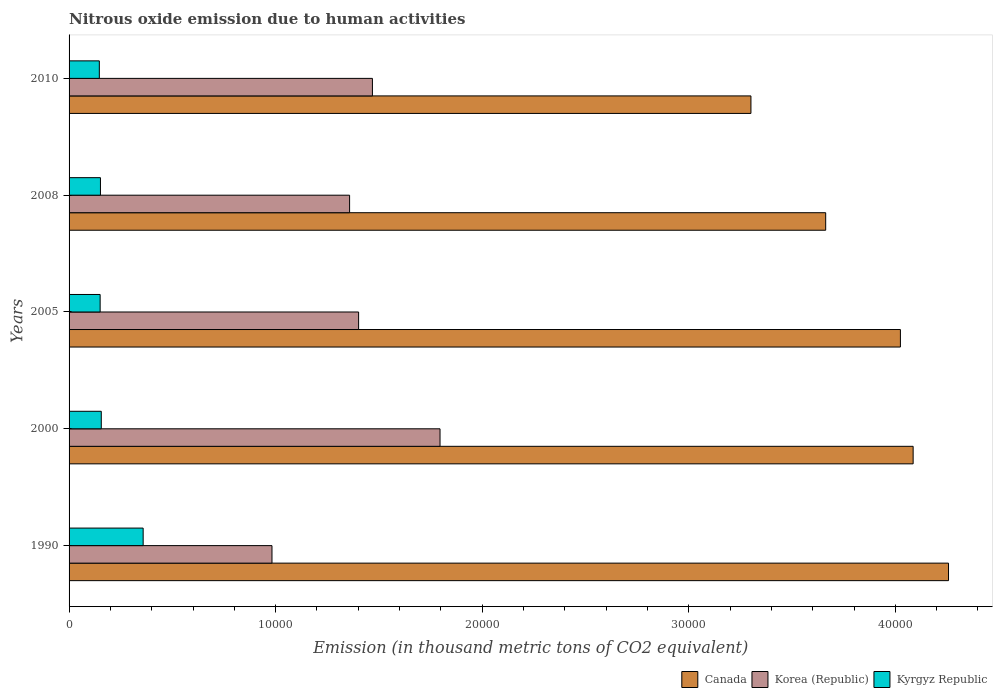Are the number of bars on each tick of the Y-axis equal?
Provide a succinct answer. Yes. What is the label of the 3rd group of bars from the top?
Your answer should be very brief. 2005. What is the amount of nitrous oxide emitted in Korea (Republic) in 2008?
Your answer should be compact. 1.36e+04. Across all years, what is the maximum amount of nitrous oxide emitted in Kyrgyz Republic?
Offer a terse response. 3586.5. Across all years, what is the minimum amount of nitrous oxide emitted in Kyrgyz Republic?
Give a very brief answer. 1465. What is the total amount of nitrous oxide emitted in Korea (Republic) in the graph?
Ensure brevity in your answer.  7.01e+04. What is the difference between the amount of nitrous oxide emitted in Korea (Republic) in 2000 and that in 2010?
Make the answer very short. 3272.5. What is the difference between the amount of nitrous oxide emitted in Korea (Republic) in 2005 and the amount of nitrous oxide emitted in Kyrgyz Republic in 2008?
Offer a very short reply. 1.25e+04. What is the average amount of nitrous oxide emitted in Kyrgyz Republic per year?
Your response must be concise. 1926.84. In the year 2008, what is the difference between the amount of nitrous oxide emitted in Kyrgyz Republic and amount of nitrous oxide emitted in Korea (Republic)?
Your answer should be very brief. -1.21e+04. What is the ratio of the amount of nitrous oxide emitted in Canada in 2005 to that in 2010?
Give a very brief answer. 1.22. Is the amount of nitrous oxide emitted in Korea (Republic) in 2005 less than that in 2008?
Give a very brief answer. No. What is the difference between the highest and the second highest amount of nitrous oxide emitted in Kyrgyz Republic?
Your answer should be compact. 2027.4. What is the difference between the highest and the lowest amount of nitrous oxide emitted in Kyrgyz Republic?
Make the answer very short. 2121.5. In how many years, is the amount of nitrous oxide emitted in Korea (Republic) greater than the average amount of nitrous oxide emitted in Korea (Republic) taken over all years?
Your response must be concise. 3. Is the sum of the amount of nitrous oxide emitted in Korea (Republic) in 1990 and 2008 greater than the maximum amount of nitrous oxide emitted in Kyrgyz Republic across all years?
Offer a very short reply. Yes. What does the 1st bar from the top in 2010 represents?
Provide a succinct answer. Kyrgyz Republic. How many bars are there?
Provide a short and direct response. 15. Are all the bars in the graph horizontal?
Your response must be concise. Yes. How many years are there in the graph?
Ensure brevity in your answer.  5. Are the values on the major ticks of X-axis written in scientific E-notation?
Provide a succinct answer. No. Does the graph contain grids?
Your answer should be compact. No. How are the legend labels stacked?
Your answer should be very brief. Horizontal. What is the title of the graph?
Your response must be concise. Nitrous oxide emission due to human activities. Does "Northern Mariana Islands" appear as one of the legend labels in the graph?
Ensure brevity in your answer.  No. What is the label or title of the X-axis?
Your answer should be very brief. Emission (in thousand metric tons of CO2 equivalent). What is the label or title of the Y-axis?
Provide a short and direct response. Years. What is the Emission (in thousand metric tons of CO2 equivalent) in Canada in 1990?
Offer a very short reply. 4.26e+04. What is the Emission (in thousand metric tons of CO2 equivalent) in Korea (Republic) in 1990?
Give a very brief answer. 9823.4. What is the Emission (in thousand metric tons of CO2 equivalent) in Kyrgyz Republic in 1990?
Your answer should be very brief. 3586.5. What is the Emission (in thousand metric tons of CO2 equivalent) of Canada in 2000?
Offer a terse response. 4.09e+04. What is the Emission (in thousand metric tons of CO2 equivalent) in Korea (Republic) in 2000?
Ensure brevity in your answer.  1.80e+04. What is the Emission (in thousand metric tons of CO2 equivalent) of Kyrgyz Republic in 2000?
Give a very brief answer. 1559.1. What is the Emission (in thousand metric tons of CO2 equivalent) in Canada in 2005?
Provide a succinct answer. 4.02e+04. What is the Emission (in thousand metric tons of CO2 equivalent) in Korea (Republic) in 2005?
Make the answer very short. 1.40e+04. What is the Emission (in thousand metric tons of CO2 equivalent) in Kyrgyz Republic in 2005?
Provide a short and direct response. 1504.3. What is the Emission (in thousand metric tons of CO2 equivalent) in Canada in 2008?
Offer a very short reply. 3.66e+04. What is the Emission (in thousand metric tons of CO2 equivalent) in Korea (Republic) in 2008?
Your response must be concise. 1.36e+04. What is the Emission (in thousand metric tons of CO2 equivalent) of Kyrgyz Republic in 2008?
Offer a very short reply. 1519.3. What is the Emission (in thousand metric tons of CO2 equivalent) of Canada in 2010?
Ensure brevity in your answer.  3.30e+04. What is the Emission (in thousand metric tons of CO2 equivalent) of Korea (Republic) in 2010?
Make the answer very short. 1.47e+04. What is the Emission (in thousand metric tons of CO2 equivalent) of Kyrgyz Republic in 2010?
Your response must be concise. 1465. Across all years, what is the maximum Emission (in thousand metric tons of CO2 equivalent) of Canada?
Give a very brief answer. 4.26e+04. Across all years, what is the maximum Emission (in thousand metric tons of CO2 equivalent) in Korea (Republic)?
Your answer should be compact. 1.80e+04. Across all years, what is the maximum Emission (in thousand metric tons of CO2 equivalent) in Kyrgyz Republic?
Offer a terse response. 3586.5. Across all years, what is the minimum Emission (in thousand metric tons of CO2 equivalent) of Canada?
Your response must be concise. 3.30e+04. Across all years, what is the minimum Emission (in thousand metric tons of CO2 equivalent) of Korea (Republic)?
Your response must be concise. 9823.4. Across all years, what is the minimum Emission (in thousand metric tons of CO2 equivalent) in Kyrgyz Republic?
Your answer should be very brief. 1465. What is the total Emission (in thousand metric tons of CO2 equivalent) in Canada in the graph?
Give a very brief answer. 1.93e+05. What is the total Emission (in thousand metric tons of CO2 equivalent) of Korea (Republic) in the graph?
Your response must be concise. 7.01e+04. What is the total Emission (in thousand metric tons of CO2 equivalent) in Kyrgyz Republic in the graph?
Provide a succinct answer. 9634.2. What is the difference between the Emission (in thousand metric tons of CO2 equivalent) in Canada in 1990 and that in 2000?
Your answer should be very brief. 1712.6. What is the difference between the Emission (in thousand metric tons of CO2 equivalent) of Korea (Republic) in 1990 and that in 2000?
Provide a succinct answer. -8134.7. What is the difference between the Emission (in thousand metric tons of CO2 equivalent) of Kyrgyz Republic in 1990 and that in 2000?
Provide a succinct answer. 2027.4. What is the difference between the Emission (in thousand metric tons of CO2 equivalent) in Canada in 1990 and that in 2005?
Ensure brevity in your answer.  2329.2. What is the difference between the Emission (in thousand metric tons of CO2 equivalent) in Korea (Republic) in 1990 and that in 2005?
Give a very brief answer. -4193. What is the difference between the Emission (in thousand metric tons of CO2 equivalent) of Kyrgyz Republic in 1990 and that in 2005?
Your answer should be very brief. 2082.2. What is the difference between the Emission (in thousand metric tons of CO2 equivalent) in Canada in 1990 and that in 2008?
Keep it short and to the point. 5946.6. What is the difference between the Emission (in thousand metric tons of CO2 equivalent) of Korea (Republic) in 1990 and that in 2008?
Your answer should be very brief. -3756.8. What is the difference between the Emission (in thousand metric tons of CO2 equivalent) in Kyrgyz Republic in 1990 and that in 2008?
Ensure brevity in your answer.  2067.2. What is the difference between the Emission (in thousand metric tons of CO2 equivalent) of Canada in 1990 and that in 2010?
Offer a very short reply. 9564.7. What is the difference between the Emission (in thousand metric tons of CO2 equivalent) of Korea (Republic) in 1990 and that in 2010?
Your answer should be very brief. -4862.2. What is the difference between the Emission (in thousand metric tons of CO2 equivalent) in Kyrgyz Republic in 1990 and that in 2010?
Offer a terse response. 2121.5. What is the difference between the Emission (in thousand metric tons of CO2 equivalent) in Canada in 2000 and that in 2005?
Give a very brief answer. 616.6. What is the difference between the Emission (in thousand metric tons of CO2 equivalent) of Korea (Republic) in 2000 and that in 2005?
Offer a terse response. 3941.7. What is the difference between the Emission (in thousand metric tons of CO2 equivalent) in Kyrgyz Republic in 2000 and that in 2005?
Give a very brief answer. 54.8. What is the difference between the Emission (in thousand metric tons of CO2 equivalent) of Canada in 2000 and that in 2008?
Give a very brief answer. 4234. What is the difference between the Emission (in thousand metric tons of CO2 equivalent) in Korea (Republic) in 2000 and that in 2008?
Ensure brevity in your answer.  4377.9. What is the difference between the Emission (in thousand metric tons of CO2 equivalent) of Kyrgyz Republic in 2000 and that in 2008?
Your response must be concise. 39.8. What is the difference between the Emission (in thousand metric tons of CO2 equivalent) of Canada in 2000 and that in 2010?
Your response must be concise. 7852.1. What is the difference between the Emission (in thousand metric tons of CO2 equivalent) of Korea (Republic) in 2000 and that in 2010?
Your response must be concise. 3272.5. What is the difference between the Emission (in thousand metric tons of CO2 equivalent) in Kyrgyz Republic in 2000 and that in 2010?
Offer a terse response. 94.1. What is the difference between the Emission (in thousand metric tons of CO2 equivalent) of Canada in 2005 and that in 2008?
Offer a terse response. 3617.4. What is the difference between the Emission (in thousand metric tons of CO2 equivalent) in Korea (Republic) in 2005 and that in 2008?
Your response must be concise. 436.2. What is the difference between the Emission (in thousand metric tons of CO2 equivalent) in Kyrgyz Republic in 2005 and that in 2008?
Make the answer very short. -15. What is the difference between the Emission (in thousand metric tons of CO2 equivalent) in Canada in 2005 and that in 2010?
Give a very brief answer. 7235.5. What is the difference between the Emission (in thousand metric tons of CO2 equivalent) of Korea (Republic) in 2005 and that in 2010?
Your answer should be very brief. -669.2. What is the difference between the Emission (in thousand metric tons of CO2 equivalent) in Kyrgyz Republic in 2005 and that in 2010?
Make the answer very short. 39.3. What is the difference between the Emission (in thousand metric tons of CO2 equivalent) of Canada in 2008 and that in 2010?
Ensure brevity in your answer.  3618.1. What is the difference between the Emission (in thousand metric tons of CO2 equivalent) in Korea (Republic) in 2008 and that in 2010?
Ensure brevity in your answer.  -1105.4. What is the difference between the Emission (in thousand metric tons of CO2 equivalent) in Kyrgyz Republic in 2008 and that in 2010?
Your answer should be compact. 54.3. What is the difference between the Emission (in thousand metric tons of CO2 equivalent) in Canada in 1990 and the Emission (in thousand metric tons of CO2 equivalent) in Korea (Republic) in 2000?
Give a very brief answer. 2.46e+04. What is the difference between the Emission (in thousand metric tons of CO2 equivalent) in Canada in 1990 and the Emission (in thousand metric tons of CO2 equivalent) in Kyrgyz Republic in 2000?
Keep it short and to the point. 4.10e+04. What is the difference between the Emission (in thousand metric tons of CO2 equivalent) in Korea (Republic) in 1990 and the Emission (in thousand metric tons of CO2 equivalent) in Kyrgyz Republic in 2000?
Your answer should be compact. 8264.3. What is the difference between the Emission (in thousand metric tons of CO2 equivalent) of Canada in 1990 and the Emission (in thousand metric tons of CO2 equivalent) of Korea (Republic) in 2005?
Keep it short and to the point. 2.86e+04. What is the difference between the Emission (in thousand metric tons of CO2 equivalent) in Canada in 1990 and the Emission (in thousand metric tons of CO2 equivalent) in Kyrgyz Republic in 2005?
Offer a very short reply. 4.11e+04. What is the difference between the Emission (in thousand metric tons of CO2 equivalent) of Korea (Republic) in 1990 and the Emission (in thousand metric tons of CO2 equivalent) of Kyrgyz Republic in 2005?
Keep it short and to the point. 8319.1. What is the difference between the Emission (in thousand metric tons of CO2 equivalent) in Canada in 1990 and the Emission (in thousand metric tons of CO2 equivalent) in Korea (Republic) in 2008?
Keep it short and to the point. 2.90e+04. What is the difference between the Emission (in thousand metric tons of CO2 equivalent) in Canada in 1990 and the Emission (in thousand metric tons of CO2 equivalent) in Kyrgyz Republic in 2008?
Give a very brief answer. 4.11e+04. What is the difference between the Emission (in thousand metric tons of CO2 equivalent) in Korea (Republic) in 1990 and the Emission (in thousand metric tons of CO2 equivalent) in Kyrgyz Republic in 2008?
Offer a terse response. 8304.1. What is the difference between the Emission (in thousand metric tons of CO2 equivalent) of Canada in 1990 and the Emission (in thousand metric tons of CO2 equivalent) of Korea (Republic) in 2010?
Make the answer very short. 2.79e+04. What is the difference between the Emission (in thousand metric tons of CO2 equivalent) in Canada in 1990 and the Emission (in thousand metric tons of CO2 equivalent) in Kyrgyz Republic in 2010?
Your response must be concise. 4.11e+04. What is the difference between the Emission (in thousand metric tons of CO2 equivalent) of Korea (Republic) in 1990 and the Emission (in thousand metric tons of CO2 equivalent) of Kyrgyz Republic in 2010?
Offer a very short reply. 8358.4. What is the difference between the Emission (in thousand metric tons of CO2 equivalent) of Canada in 2000 and the Emission (in thousand metric tons of CO2 equivalent) of Korea (Republic) in 2005?
Keep it short and to the point. 2.68e+04. What is the difference between the Emission (in thousand metric tons of CO2 equivalent) of Canada in 2000 and the Emission (in thousand metric tons of CO2 equivalent) of Kyrgyz Republic in 2005?
Offer a very short reply. 3.94e+04. What is the difference between the Emission (in thousand metric tons of CO2 equivalent) in Korea (Republic) in 2000 and the Emission (in thousand metric tons of CO2 equivalent) in Kyrgyz Republic in 2005?
Offer a terse response. 1.65e+04. What is the difference between the Emission (in thousand metric tons of CO2 equivalent) in Canada in 2000 and the Emission (in thousand metric tons of CO2 equivalent) in Korea (Republic) in 2008?
Provide a short and direct response. 2.73e+04. What is the difference between the Emission (in thousand metric tons of CO2 equivalent) in Canada in 2000 and the Emission (in thousand metric tons of CO2 equivalent) in Kyrgyz Republic in 2008?
Your answer should be compact. 3.93e+04. What is the difference between the Emission (in thousand metric tons of CO2 equivalent) of Korea (Republic) in 2000 and the Emission (in thousand metric tons of CO2 equivalent) of Kyrgyz Republic in 2008?
Provide a short and direct response. 1.64e+04. What is the difference between the Emission (in thousand metric tons of CO2 equivalent) in Canada in 2000 and the Emission (in thousand metric tons of CO2 equivalent) in Korea (Republic) in 2010?
Offer a terse response. 2.62e+04. What is the difference between the Emission (in thousand metric tons of CO2 equivalent) in Canada in 2000 and the Emission (in thousand metric tons of CO2 equivalent) in Kyrgyz Republic in 2010?
Make the answer very short. 3.94e+04. What is the difference between the Emission (in thousand metric tons of CO2 equivalent) of Korea (Republic) in 2000 and the Emission (in thousand metric tons of CO2 equivalent) of Kyrgyz Republic in 2010?
Offer a very short reply. 1.65e+04. What is the difference between the Emission (in thousand metric tons of CO2 equivalent) in Canada in 2005 and the Emission (in thousand metric tons of CO2 equivalent) in Korea (Republic) in 2008?
Your answer should be compact. 2.67e+04. What is the difference between the Emission (in thousand metric tons of CO2 equivalent) in Canada in 2005 and the Emission (in thousand metric tons of CO2 equivalent) in Kyrgyz Republic in 2008?
Make the answer very short. 3.87e+04. What is the difference between the Emission (in thousand metric tons of CO2 equivalent) in Korea (Republic) in 2005 and the Emission (in thousand metric tons of CO2 equivalent) in Kyrgyz Republic in 2008?
Your answer should be very brief. 1.25e+04. What is the difference between the Emission (in thousand metric tons of CO2 equivalent) in Canada in 2005 and the Emission (in thousand metric tons of CO2 equivalent) in Korea (Republic) in 2010?
Ensure brevity in your answer.  2.56e+04. What is the difference between the Emission (in thousand metric tons of CO2 equivalent) of Canada in 2005 and the Emission (in thousand metric tons of CO2 equivalent) of Kyrgyz Republic in 2010?
Your response must be concise. 3.88e+04. What is the difference between the Emission (in thousand metric tons of CO2 equivalent) of Korea (Republic) in 2005 and the Emission (in thousand metric tons of CO2 equivalent) of Kyrgyz Republic in 2010?
Ensure brevity in your answer.  1.26e+04. What is the difference between the Emission (in thousand metric tons of CO2 equivalent) of Canada in 2008 and the Emission (in thousand metric tons of CO2 equivalent) of Korea (Republic) in 2010?
Offer a terse response. 2.19e+04. What is the difference between the Emission (in thousand metric tons of CO2 equivalent) of Canada in 2008 and the Emission (in thousand metric tons of CO2 equivalent) of Kyrgyz Republic in 2010?
Your answer should be compact. 3.52e+04. What is the difference between the Emission (in thousand metric tons of CO2 equivalent) in Korea (Republic) in 2008 and the Emission (in thousand metric tons of CO2 equivalent) in Kyrgyz Republic in 2010?
Your response must be concise. 1.21e+04. What is the average Emission (in thousand metric tons of CO2 equivalent) of Canada per year?
Make the answer very short. 3.87e+04. What is the average Emission (in thousand metric tons of CO2 equivalent) in Korea (Republic) per year?
Give a very brief answer. 1.40e+04. What is the average Emission (in thousand metric tons of CO2 equivalent) in Kyrgyz Republic per year?
Provide a succinct answer. 1926.84. In the year 1990, what is the difference between the Emission (in thousand metric tons of CO2 equivalent) in Canada and Emission (in thousand metric tons of CO2 equivalent) in Korea (Republic)?
Provide a short and direct response. 3.28e+04. In the year 1990, what is the difference between the Emission (in thousand metric tons of CO2 equivalent) of Canada and Emission (in thousand metric tons of CO2 equivalent) of Kyrgyz Republic?
Your answer should be compact. 3.90e+04. In the year 1990, what is the difference between the Emission (in thousand metric tons of CO2 equivalent) of Korea (Republic) and Emission (in thousand metric tons of CO2 equivalent) of Kyrgyz Republic?
Provide a succinct answer. 6236.9. In the year 2000, what is the difference between the Emission (in thousand metric tons of CO2 equivalent) in Canada and Emission (in thousand metric tons of CO2 equivalent) in Korea (Republic)?
Offer a very short reply. 2.29e+04. In the year 2000, what is the difference between the Emission (in thousand metric tons of CO2 equivalent) of Canada and Emission (in thousand metric tons of CO2 equivalent) of Kyrgyz Republic?
Offer a terse response. 3.93e+04. In the year 2000, what is the difference between the Emission (in thousand metric tons of CO2 equivalent) of Korea (Republic) and Emission (in thousand metric tons of CO2 equivalent) of Kyrgyz Republic?
Make the answer very short. 1.64e+04. In the year 2005, what is the difference between the Emission (in thousand metric tons of CO2 equivalent) in Canada and Emission (in thousand metric tons of CO2 equivalent) in Korea (Republic)?
Keep it short and to the point. 2.62e+04. In the year 2005, what is the difference between the Emission (in thousand metric tons of CO2 equivalent) in Canada and Emission (in thousand metric tons of CO2 equivalent) in Kyrgyz Republic?
Your answer should be very brief. 3.87e+04. In the year 2005, what is the difference between the Emission (in thousand metric tons of CO2 equivalent) in Korea (Republic) and Emission (in thousand metric tons of CO2 equivalent) in Kyrgyz Republic?
Make the answer very short. 1.25e+04. In the year 2008, what is the difference between the Emission (in thousand metric tons of CO2 equivalent) of Canada and Emission (in thousand metric tons of CO2 equivalent) of Korea (Republic)?
Ensure brevity in your answer.  2.30e+04. In the year 2008, what is the difference between the Emission (in thousand metric tons of CO2 equivalent) of Canada and Emission (in thousand metric tons of CO2 equivalent) of Kyrgyz Republic?
Offer a very short reply. 3.51e+04. In the year 2008, what is the difference between the Emission (in thousand metric tons of CO2 equivalent) in Korea (Republic) and Emission (in thousand metric tons of CO2 equivalent) in Kyrgyz Republic?
Make the answer very short. 1.21e+04. In the year 2010, what is the difference between the Emission (in thousand metric tons of CO2 equivalent) of Canada and Emission (in thousand metric tons of CO2 equivalent) of Korea (Republic)?
Your answer should be very brief. 1.83e+04. In the year 2010, what is the difference between the Emission (in thousand metric tons of CO2 equivalent) in Canada and Emission (in thousand metric tons of CO2 equivalent) in Kyrgyz Republic?
Ensure brevity in your answer.  3.15e+04. In the year 2010, what is the difference between the Emission (in thousand metric tons of CO2 equivalent) of Korea (Republic) and Emission (in thousand metric tons of CO2 equivalent) of Kyrgyz Republic?
Keep it short and to the point. 1.32e+04. What is the ratio of the Emission (in thousand metric tons of CO2 equivalent) of Canada in 1990 to that in 2000?
Offer a terse response. 1.04. What is the ratio of the Emission (in thousand metric tons of CO2 equivalent) in Korea (Republic) in 1990 to that in 2000?
Make the answer very short. 0.55. What is the ratio of the Emission (in thousand metric tons of CO2 equivalent) in Kyrgyz Republic in 1990 to that in 2000?
Your answer should be very brief. 2.3. What is the ratio of the Emission (in thousand metric tons of CO2 equivalent) in Canada in 1990 to that in 2005?
Provide a short and direct response. 1.06. What is the ratio of the Emission (in thousand metric tons of CO2 equivalent) in Korea (Republic) in 1990 to that in 2005?
Offer a terse response. 0.7. What is the ratio of the Emission (in thousand metric tons of CO2 equivalent) in Kyrgyz Republic in 1990 to that in 2005?
Ensure brevity in your answer.  2.38. What is the ratio of the Emission (in thousand metric tons of CO2 equivalent) of Canada in 1990 to that in 2008?
Offer a very short reply. 1.16. What is the ratio of the Emission (in thousand metric tons of CO2 equivalent) of Korea (Republic) in 1990 to that in 2008?
Make the answer very short. 0.72. What is the ratio of the Emission (in thousand metric tons of CO2 equivalent) in Kyrgyz Republic in 1990 to that in 2008?
Provide a succinct answer. 2.36. What is the ratio of the Emission (in thousand metric tons of CO2 equivalent) in Canada in 1990 to that in 2010?
Give a very brief answer. 1.29. What is the ratio of the Emission (in thousand metric tons of CO2 equivalent) of Korea (Republic) in 1990 to that in 2010?
Provide a succinct answer. 0.67. What is the ratio of the Emission (in thousand metric tons of CO2 equivalent) of Kyrgyz Republic in 1990 to that in 2010?
Your answer should be very brief. 2.45. What is the ratio of the Emission (in thousand metric tons of CO2 equivalent) of Canada in 2000 to that in 2005?
Provide a succinct answer. 1.02. What is the ratio of the Emission (in thousand metric tons of CO2 equivalent) in Korea (Republic) in 2000 to that in 2005?
Provide a succinct answer. 1.28. What is the ratio of the Emission (in thousand metric tons of CO2 equivalent) of Kyrgyz Republic in 2000 to that in 2005?
Ensure brevity in your answer.  1.04. What is the ratio of the Emission (in thousand metric tons of CO2 equivalent) in Canada in 2000 to that in 2008?
Provide a short and direct response. 1.12. What is the ratio of the Emission (in thousand metric tons of CO2 equivalent) in Korea (Republic) in 2000 to that in 2008?
Your answer should be compact. 1.32. What is the ratio of the Emission (in thousand metric tons of CO2 equivalent) of Kyrgyz Republic in 2000 to that in 2008?
Your answer should be compact. 1.03. What is the ratio of the Emission (in thousand metric tons of CO2 equivalent) of Canada in 2000 to that in 2010?
Make the answer very short. 1.24. What is the ratio of the Emission (in thousand metric tons of CO2 equivalent) in Korea (Republic) in 2000 to that in 2010?
Make the answer very short. 1.22. What is the ratio of the Emission (in thousand metric tons of CO2 equivalent) in Kyrgyz Republic in 2000 to that in 2010?
Make the answer very short. 1.06. What is the ratio of the Emission (in thousand metric tons of CO2 equivalent) of Canada in 2005 to that in 2008?
Ensure brevity in your answer.  1.1. What is the ratio of the Emission (in thousand metric tons of CO2 equivalent) of Korea (Republic) in 2005 to that in 2008?
Keep it short and to the point. 1.03. What is the ratio of the Emission (in thousand metric tons of CO2 equivalent) of Canada in 2005 to that in 2010?
Your response must be concise. 1.22. What is the ratio of the Emission (in thousand metric tons of CO2 equivalent) of Korea (Republic) in 2005 to that in 2010?
Your response must be concise. 0.95. What is the ratio of the Emission (in thousand metric tons of CO2 equivalent) in Kyrgyz Republic in 2005 to that in 2010?
Provide a succinct answer. 1.03. What is the ratio of the Emission (in thousand metric tons of CO2 equivalent) of Canada in 2008 to that in 2010?
Your response must be concise. 1.11. What is the ratio of the Emission (in thousand metric tons of CO2 equivalent) in Korea (Republic) in 2008 to that in 2010?
Offer a terse response. 0.92. What is the ratio of the Emission (in thousand metric tons of CO2 equivalent) of Kyrgyz Republic in 2008 to that in 2010?
Give a very brief answer. 1.04. What is the difference between the highest and the second highest Emission (in thousand metric tons of CO2 equivalent) in Canada?
Provide a succinct answer. 1712.6. What is the difference between the highest and the second highest Emission (in thousand metric tons of CO2 equivalent) in Korea (Republic)?
Ensure brevity in your answer.  3272.5. What is the difference between the highest and the second highest Emission (in thousand metric tons of CO2 equivalent) of Kyrgyz Republic?
Provide a succinct answer. 2027.4. What is the difference between the highest and the lowest Emission (in thousand metric tons of CO2 equivalent) of Canada?
Keep it short and to the point. 9564.7. What is the difference between the highest and the lowest Emission (in thousand metric tons of CO2 equivalent) in Korea (Republic)?
Keep it short and to the point. 8134.7. What is the difference between the highest and the lowest Emission (in thousand metric tons of CO2 equivalent) of Kyrgyz Republic?
Make the answer very short. 2121.5. 